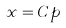Convert formula to latex. <formula><loc_0><loc_0><loc_500><loc_500>x = C p</formula> 